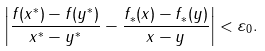<formula> <loc_0><loc_0><loc_500><loc_500>\left | \frac { f ( x ^ { * } ) - f ( y ^ { * } ) } { x ^ { * } - y ^ { * } } - \frac { f _ { * } ( x ) - f _ { * } ( y ) } { x - y } \right | < \varepsilon _ { 0 } .</formula> 